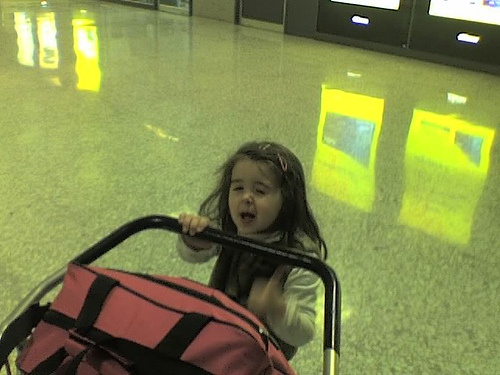Describe the objects in this image and their specific colors. I can see suitcase in olive, black, brown, and maroon tones and people in olive, black, and darkgreen tones in this image. 